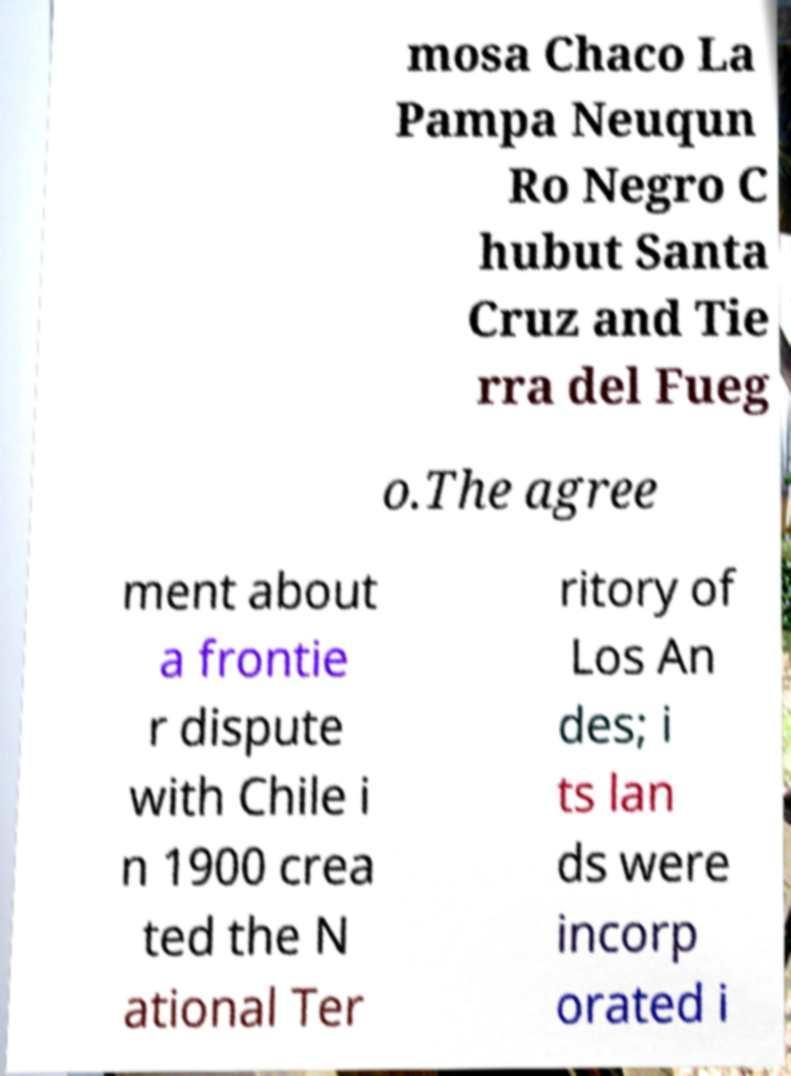Please identify and transcribe the text found in this image. mosa Chaco La Pampa Neuqun Ro Negro C hubut Santa Cruz and Tie rra del Fueg o.The agree ment about a frontie r dispute with Chile i n 1900 crea ted the N ational Ter ritory of Los An des; i ts lan ds were incorp orated i 